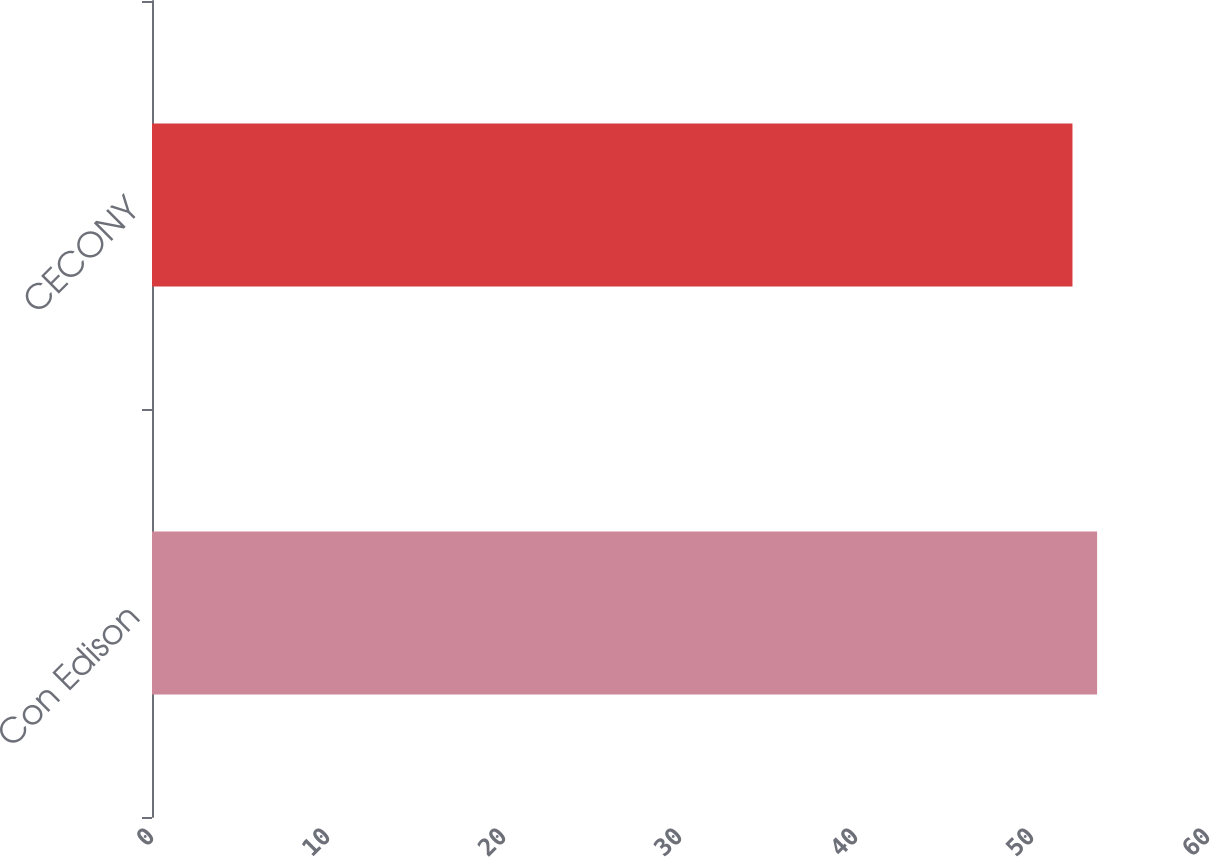<chart> <loc_0><loc_0><loc_500><loc_500><bar_chart><fcel>Con Edison<fcel>CECONY<nl><fcel>53.7<fcel>52.3<nl></chart> 